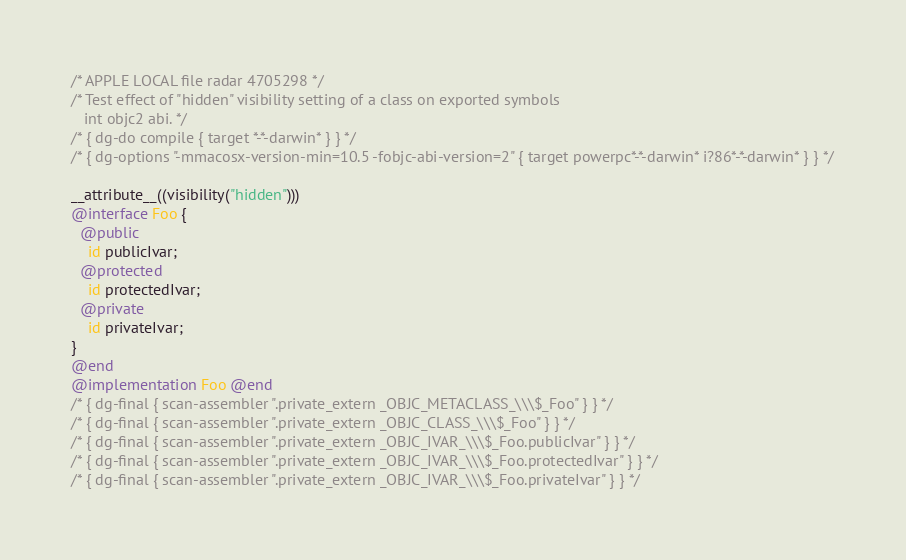Convert code to text. <code><loc_0><loc_0><loc_500><loc_500><_ObjectiveC_>/* APPLE LOCAL file radar 4705298 */
/* Test effect of "hidden" visibility setting of a class on exported symbols
   int objc2 abi. */
/* { dg-do compile { target *-*-darwin* } } */
/* { dg-options "-mmacosx-version-min=10.5 -fobjc-abi-version=2" { target powerpc*-*-darwin* i?86*-*-darwin* } } */

__attribute__((visibility("hidden"))) 
@interface Foo {
  @public
    id publicIvar;
  @protected
    id protectedIvar;
  @private
    id privateIvar;
}
@end
@implementation Foo @end
/* { dg-final { scan-assembler ".private_extern _OBJC_METACLASS_\\\$_Foo" } } */
/* { dg-final { scan-assembler ".private_extern _OBJC_CLASS_\\\$_Foo" } } */
/* { dg-final { scan-assembler ".private_extern _OBJC_IVAR_\\\$_Foo.publicIvar" } } */
/* { dg-final { scan-assembler ".private_extern _OBJC_IVAR_\\\$_Foo.protectedIvar" } } */
/* { dg-final { scan-assembler ".private_extern _OBJC_IVAR_\\\$_Foo.privateIvar" } } */
</code> 